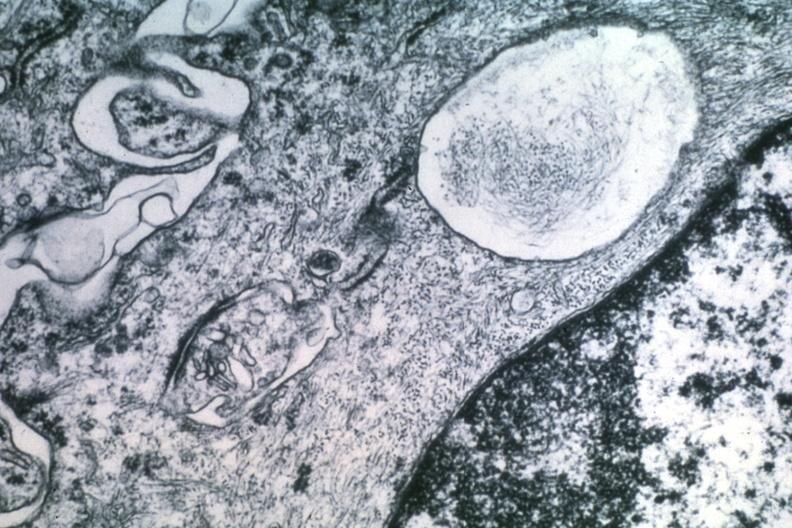s typical tuberculous exudate present?
Answer the question using a single word or phrase. No 